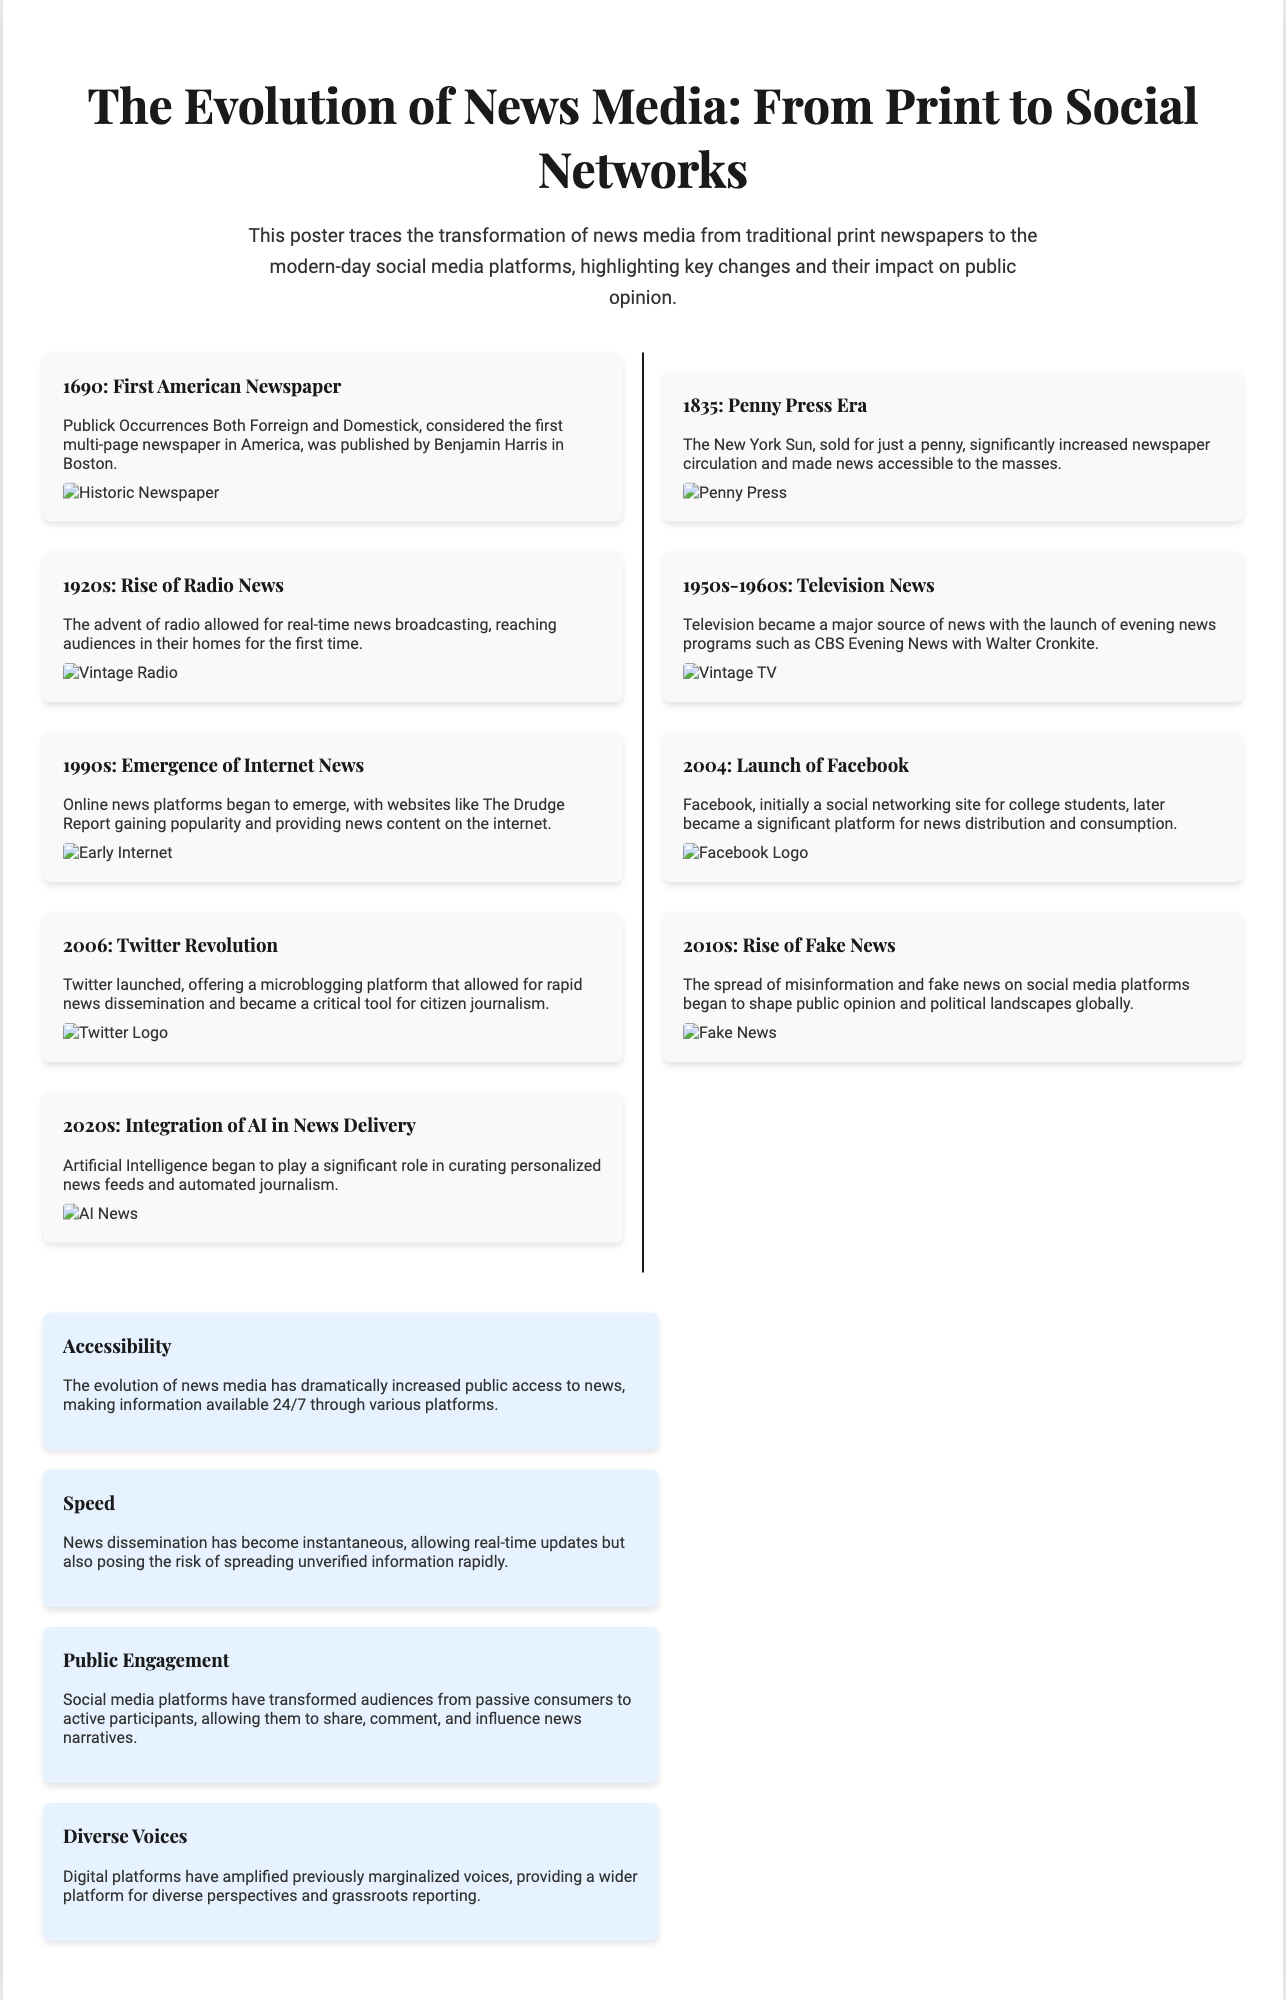What is considered the first American newspaper? The document states that "Publick Occurrences Both Forreign and Domestick" is considered the first multi-page newspaper in America, published in 1690.
Answer: Publick Occurrences Both Forreign and Domestick What year marked the launch of Facebook? According to the timeline, Facebook was launched in 2004.
Answer: 2004 Which news medium emerged in the 1920s? The poster mentions that the 1920s saw the rise of radio news as a significant medium.
Answer: Radio What is a major risk of instantaneous news dissemination? The document points out that one risk is the spreading of unverified information rapidly due to the speed of news dissemination.
Answer: Unverified information What transformation did social media platforms bring to audiences? The impact section states that social media transformed audiences from passive consumers to active participants.
Answer: Active participants What was a result of digital platforms according to the poster? It mentions that digital platforms have amplified previously marginalized voices.
Answer: Amplified marginalized voices What was a significant impact of the Penny Press era? The document highlights that the Penny Press era made news accessible to the masses, reflecting a major change in circulation.
Answer: Accessible to the masses In which decade did television become a major news source? The timeline indicates that television became a major source of news in the 1950s-1960s.
Answer: 1950s-1960s What role did Artificial Intelligence begin to play in the 2020s? The document states that AI began to play a significant role in curating personalized news feeds and automated journalism.
Answer: Personalized news feeds 